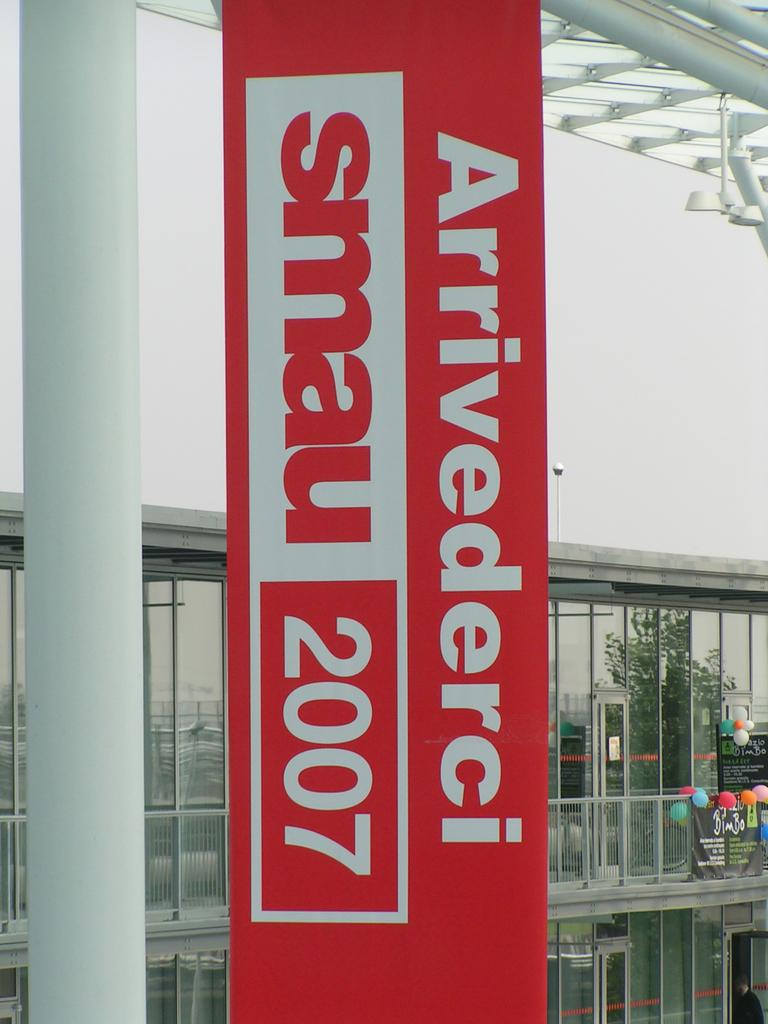What is the main object in the middle of the image? There is a board in the middle of the image, and it is red in color. What can be seen behind the board? There are glass walls behind the board. What decorative items are on the right side of the image? There are balloons on the right side of the image. Can you tell me how many doors are visible in the image? There are no doors visible in the image; only a red board, glass walls, and balloons are present. What type of yarn is being used by the team in the image? There is no team or yarn present in the image. 